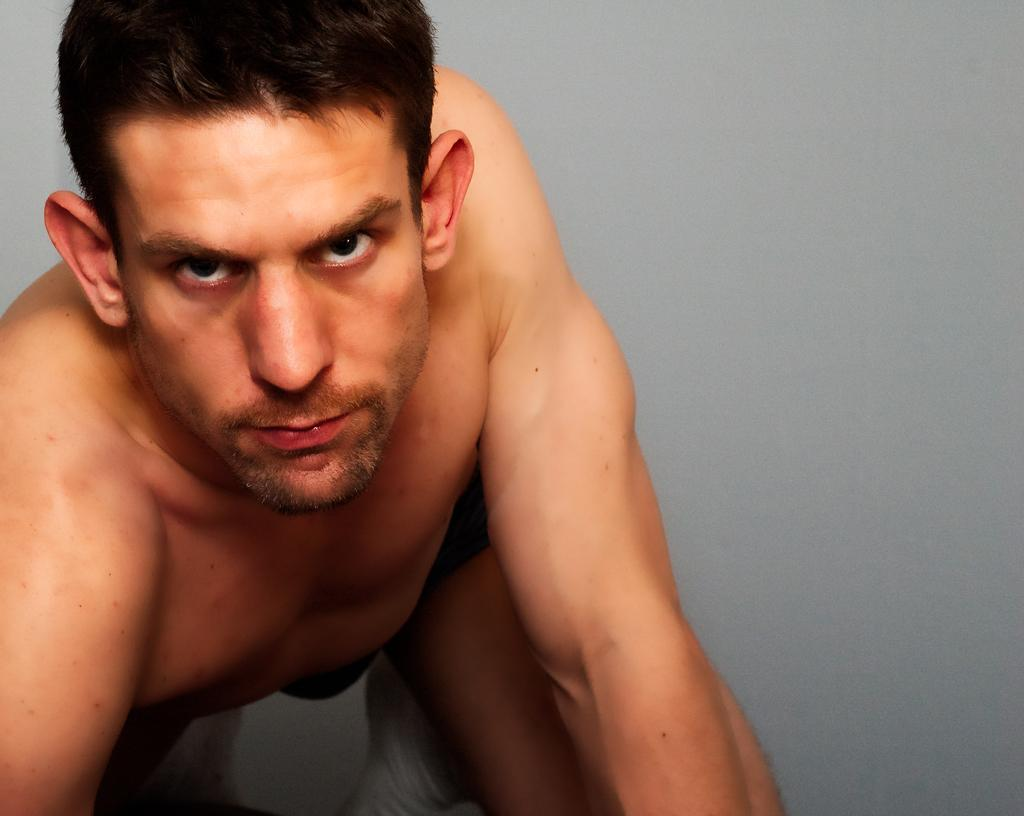What is the main subject of the image? There is a person in the image. Can you describe the background of the image? The background of the image is ash-colored. How many bushes can be seen in the image? There is no mention of bushes in the image, so we cannot determine their presence or quantity. What book is the person reading in the image? There is no book present in the image, so we cannot determine what the person might be reading. 